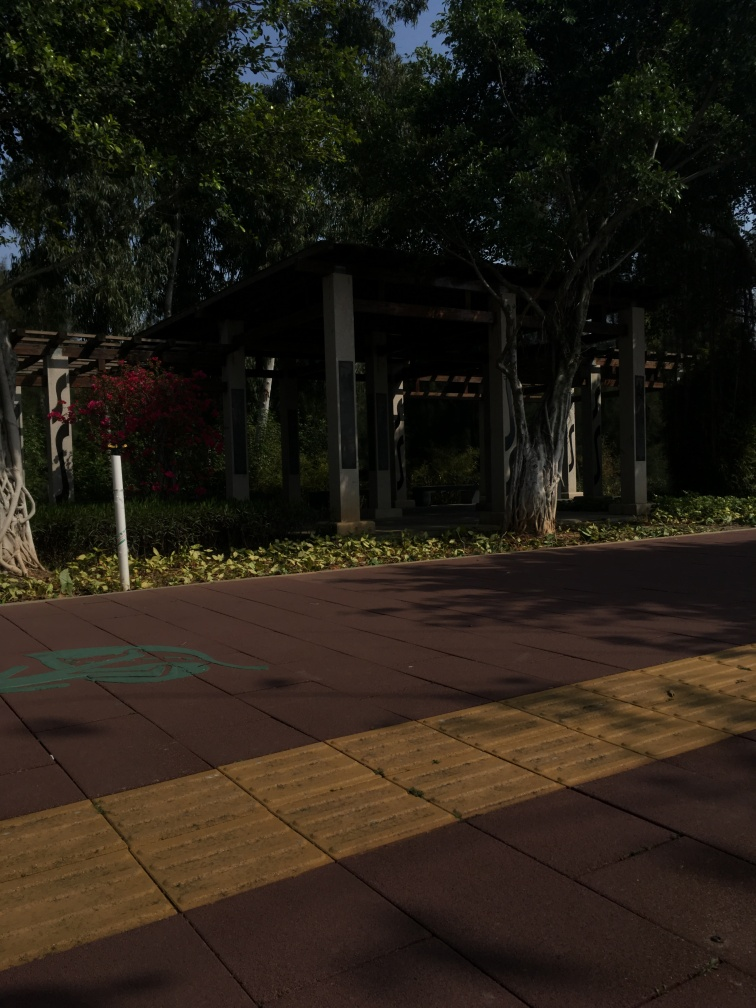Is there noise present in the image? Upon examining the image, it appears to be of high quality with no visible noise or graininess. The details within the scene, such as the textures of the tree bark, leaves, and the structure's pillars, are all distinctly visible, indicating an absence of noise and a clear, well-captured shot. 